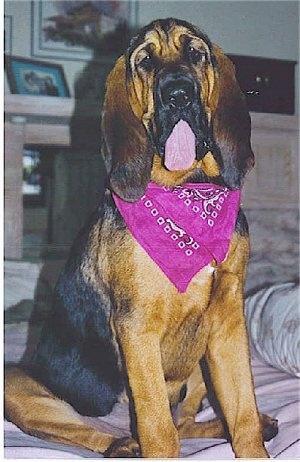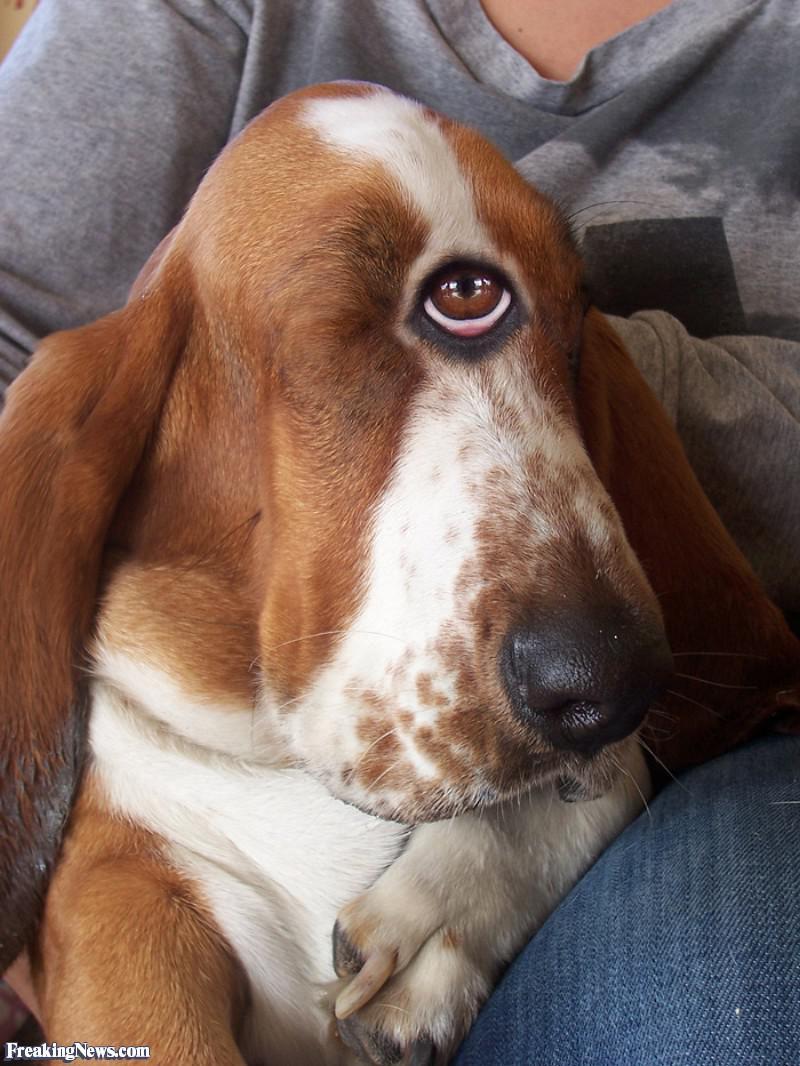The first image is the image on the left, the second image is the image on the right. For the images displayed, is the sentence "a dog is wearing a costume" factually correct? Answer yes or no. No. 